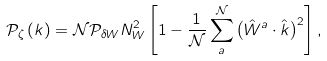Convert formula to latex. <formula><loc_0><loc_0><loc_500><loc_500>\mathcal { P } _ { \zeta } \left ( k \right ) = \mathcal { N } \mathcal { P } _ { \delta W } N _ { W } ^ { 2 } \left [ 1 - \frac { 1 } { \mathcal { N } } \sum _ { a } ^ { \mathcal { N } } \left ( \hat { W } ^ { a } \cdot \hat { k } \right ) ^ { 2 } \right ] ,</formula> 